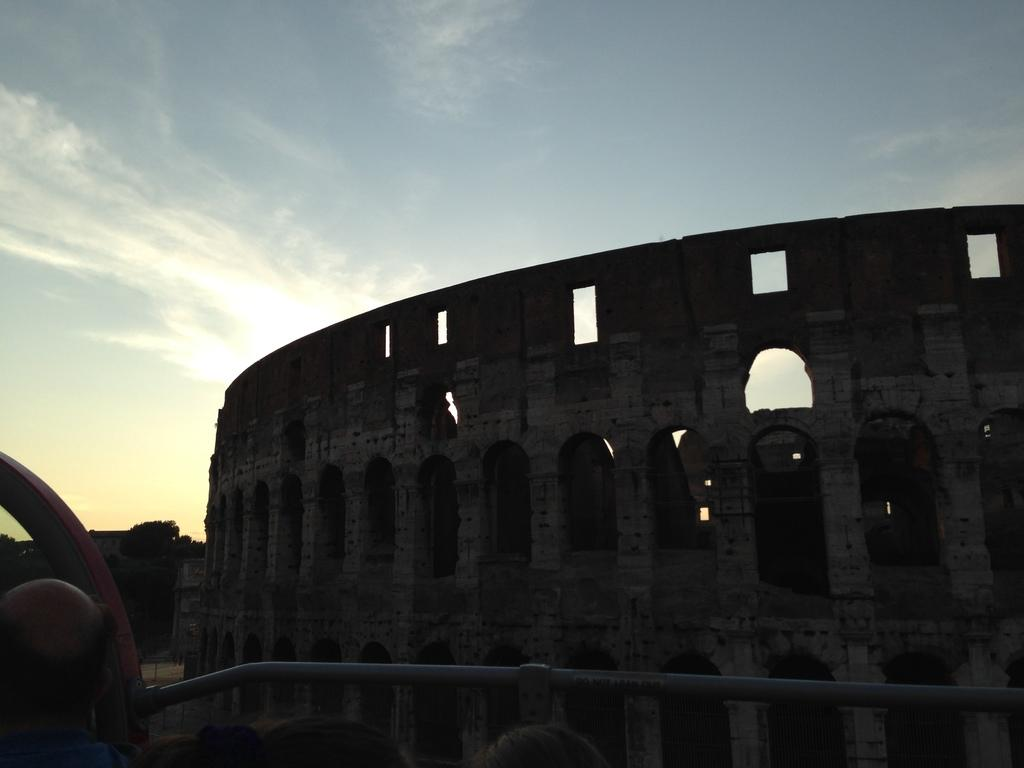What type of structure is in the image? There is a fort in the image. What can be seen in the sky at the top of the image? Clouds are visible in the sky at the top of the image. What is located at the bottom of the image? There is railing at the bottom of the image. Can you play a guitar in the image? There is no guitar present in the image. How does the liquid flow in the image? There is no liquid present in the image. 